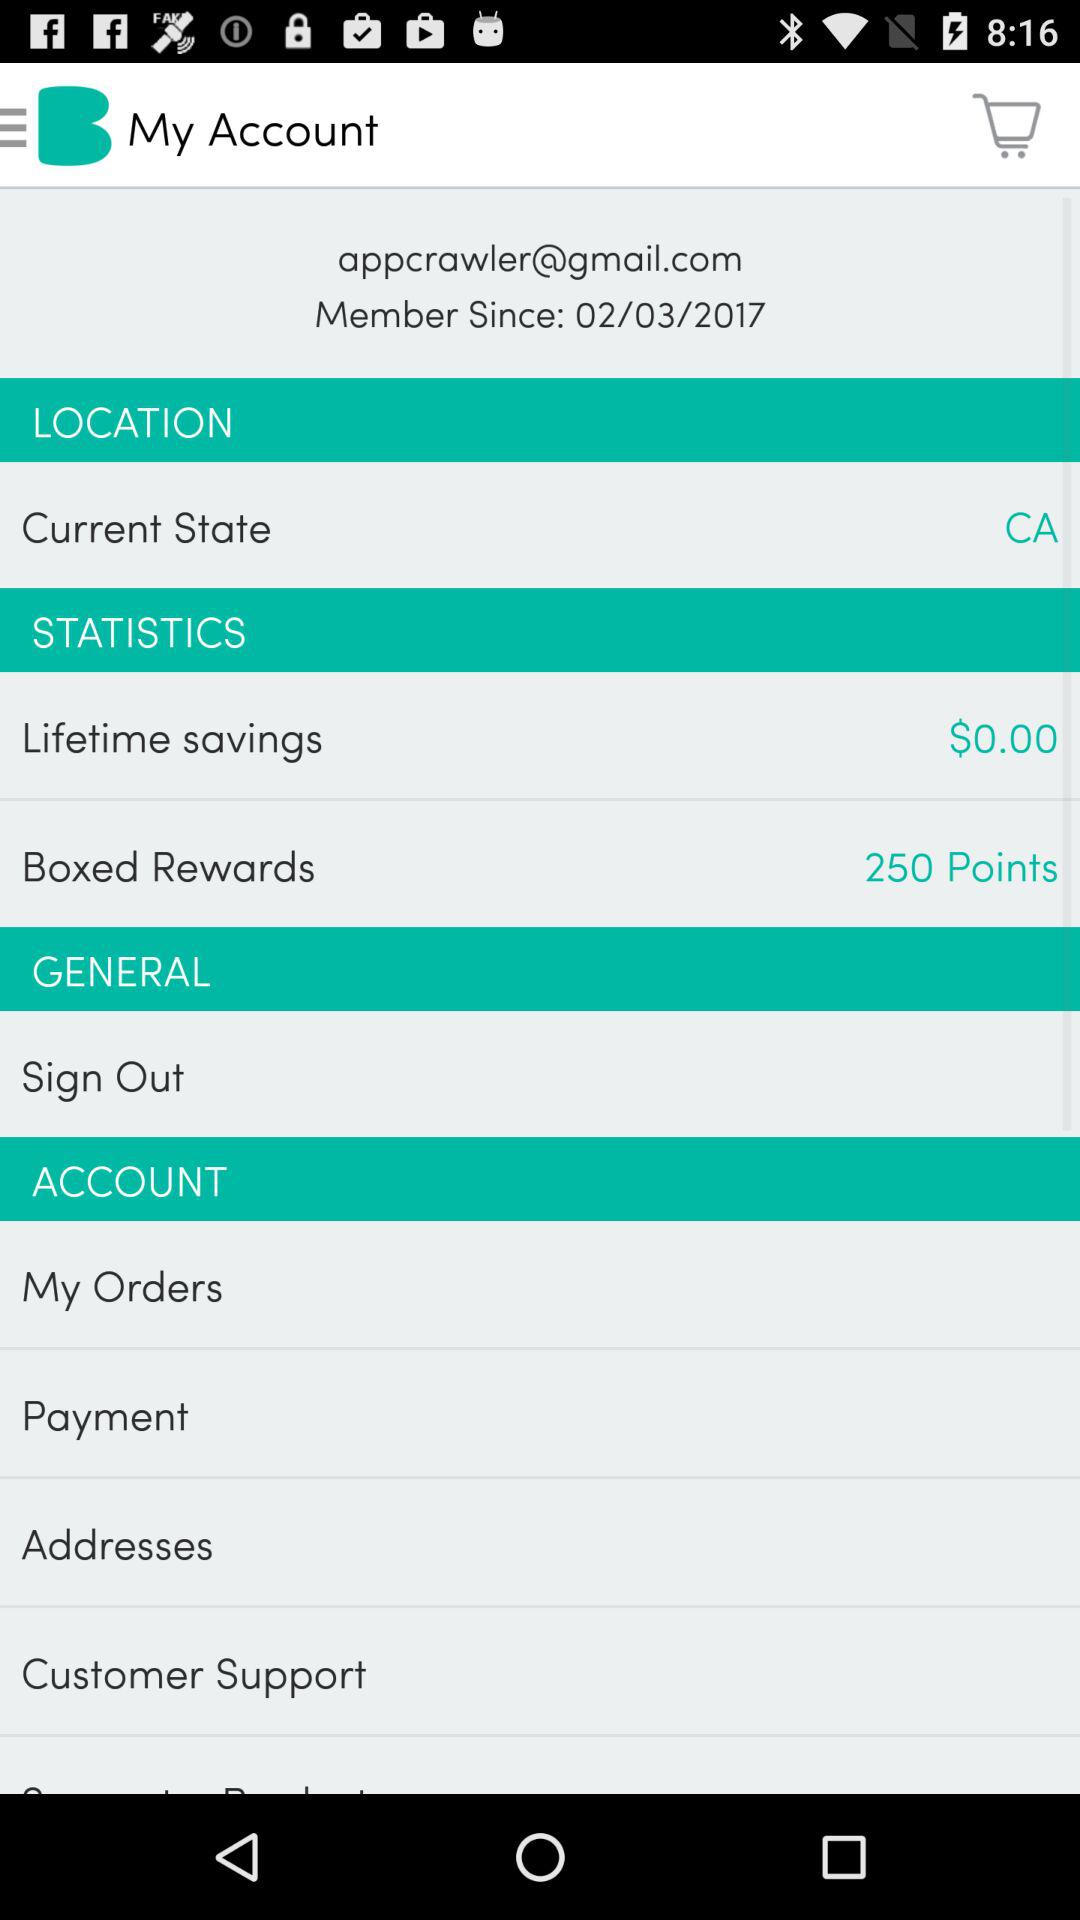What is the email address of the user? The email address of the user is appcrawler@gmail.com. 